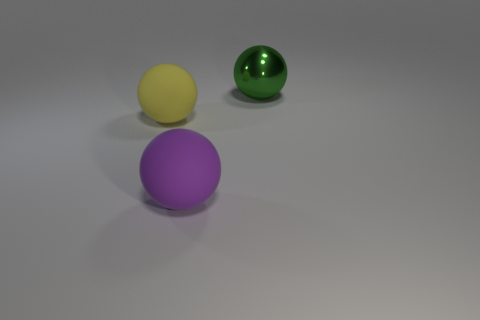Subtract all big rubber spheres. How many spheres are left? 1 Add 1 big green metal things. How many objects exist? 4 Subtract all green balls. How many balls are left? 2 Subtract all red balls. Subtract all cyan blocks. How many balls are left? 3 Subtract all red cylinders. How many yellow balls are left? 1 Subtract all green things. Subtract all big green objects. How many objects are left? 1 Add 3 matte things. How many matte things are left? 5 Add 1 large matte balls. How many large matte balls exist? 3 Subtract 1 green spheres. How many objects are left? 2 Subtract 3 balls. How many balls are left? 0 